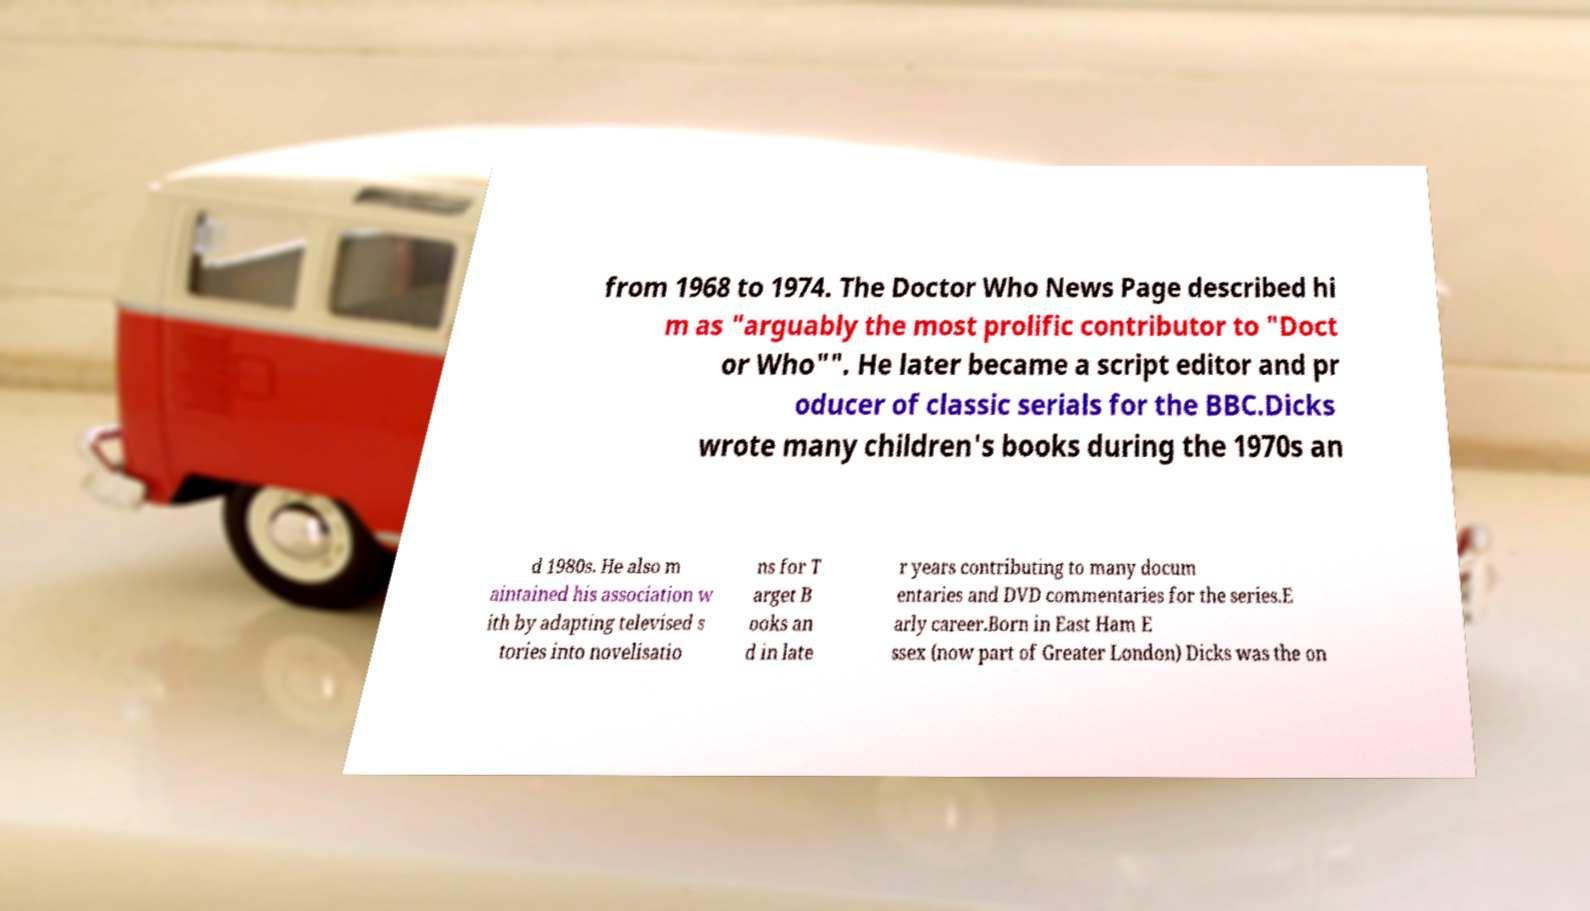Can you accurately transcribe the text from the provided image for me? from 1968 to 1974. The Doctor Who News Page described hi m as "arguably the most prolific contributor to "Doct or Who"". He later became a script editor and pr oducer of classic serials for the BBC.Dicks wrote many children's books during the 1970s an d 1980s. He also m aintained his association w ith by adapting televised s tories into novelisatio ns for T arget B ooks an d in late r years contributing to many docum entaries and DVD commentaries for the series.E arly career.Born in East Ham E ssex (now part of Greater London) Dicks was the on 